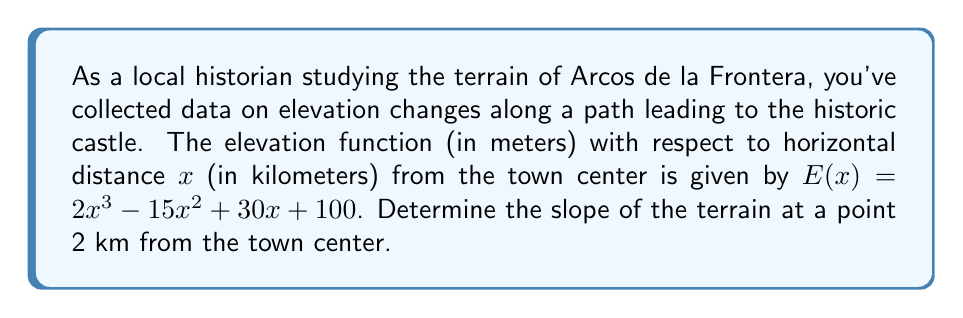Solve this math problem. To find the slope of the terrain at a specific point, we need to calculate the derivative of the elevation function and evaluate it at the given point. Let's proceed step-by-step:

1) The elevation function is given as:
   $E(x) = 2x^3 - 15x^2 + 30x + 100$

2) To find the slope, we need to calculate $E'(x)$:
   $E'(x) = \frac{d}{dx}(2x^3 - 15x^2 + 30x + 100)$

3) Apply the power rule and constant rule of differentiation:
   $E'(x) = 6x^2 - 30x + 30$

4) This function $E'(x)$ represents the slope of the terrain at any point x.

5) We need to find the slope at x = 2 km from the town center:
   $E'(2) = 6(2)^2 - 30(2) + 30$
   
6) Simplify:
   $E'(2) = 6(4) - 60 + 30 = 24 - 60 + 30 = -6$

Therefore, the slope of the terrain at a point 2 km from the town center is -6 m/km.
Answer: $-6$ m/km 